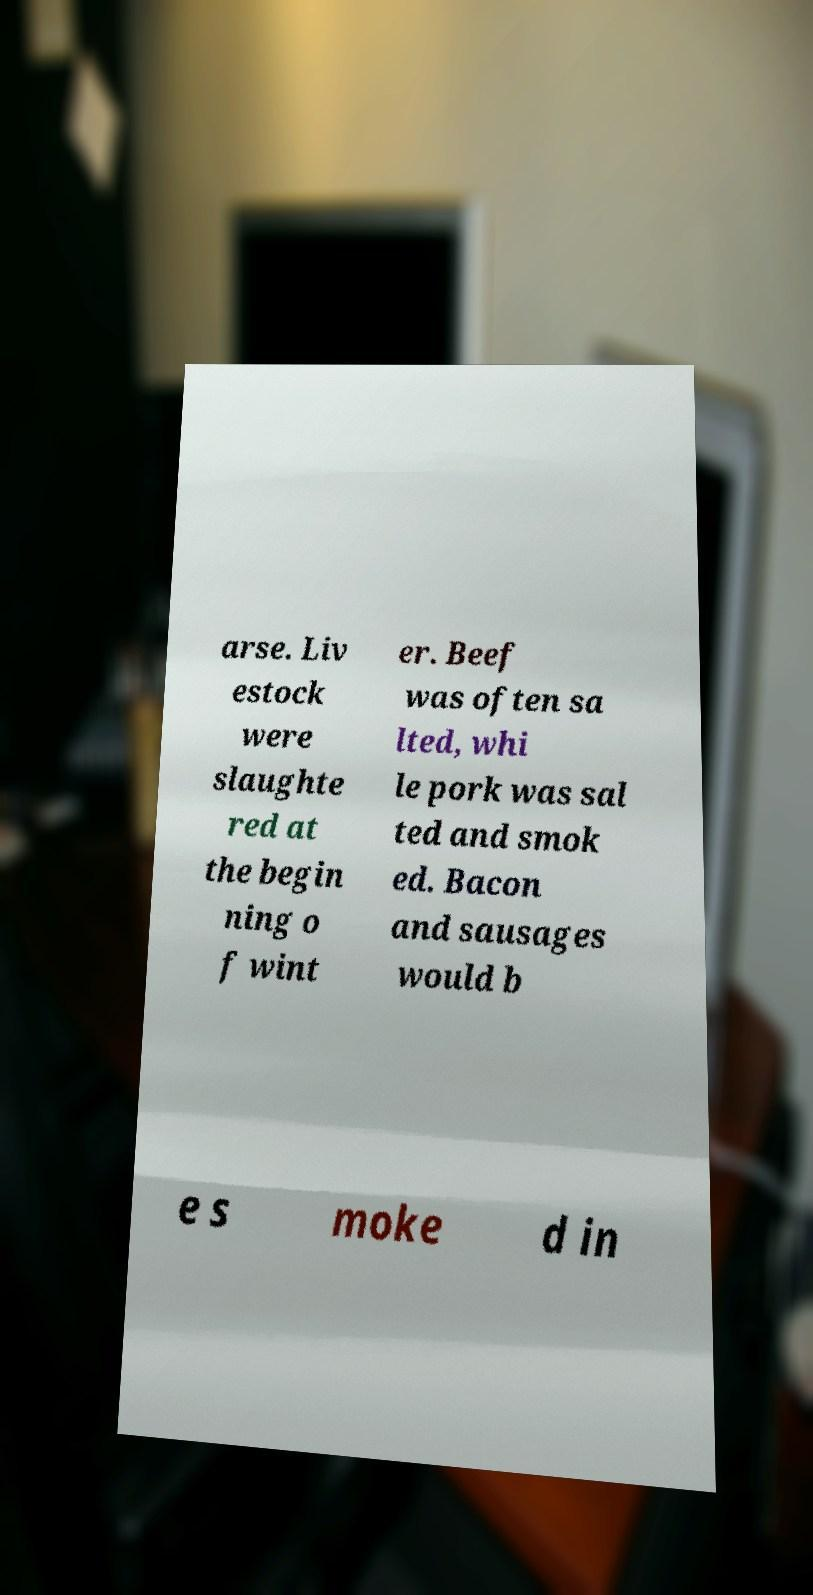I need the written content from this picture converted into text. Can you do that? arse. Liv estock were slaughte red at the begin ning o f wint er. Beef was often sa lted, whi le pork was sal ted and smok ed. Bacon and sausages would b e s moke d in 